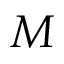Convert formula to latex. <formula><loc_0><loc_0><loc_500><loc_500>M</formula> 